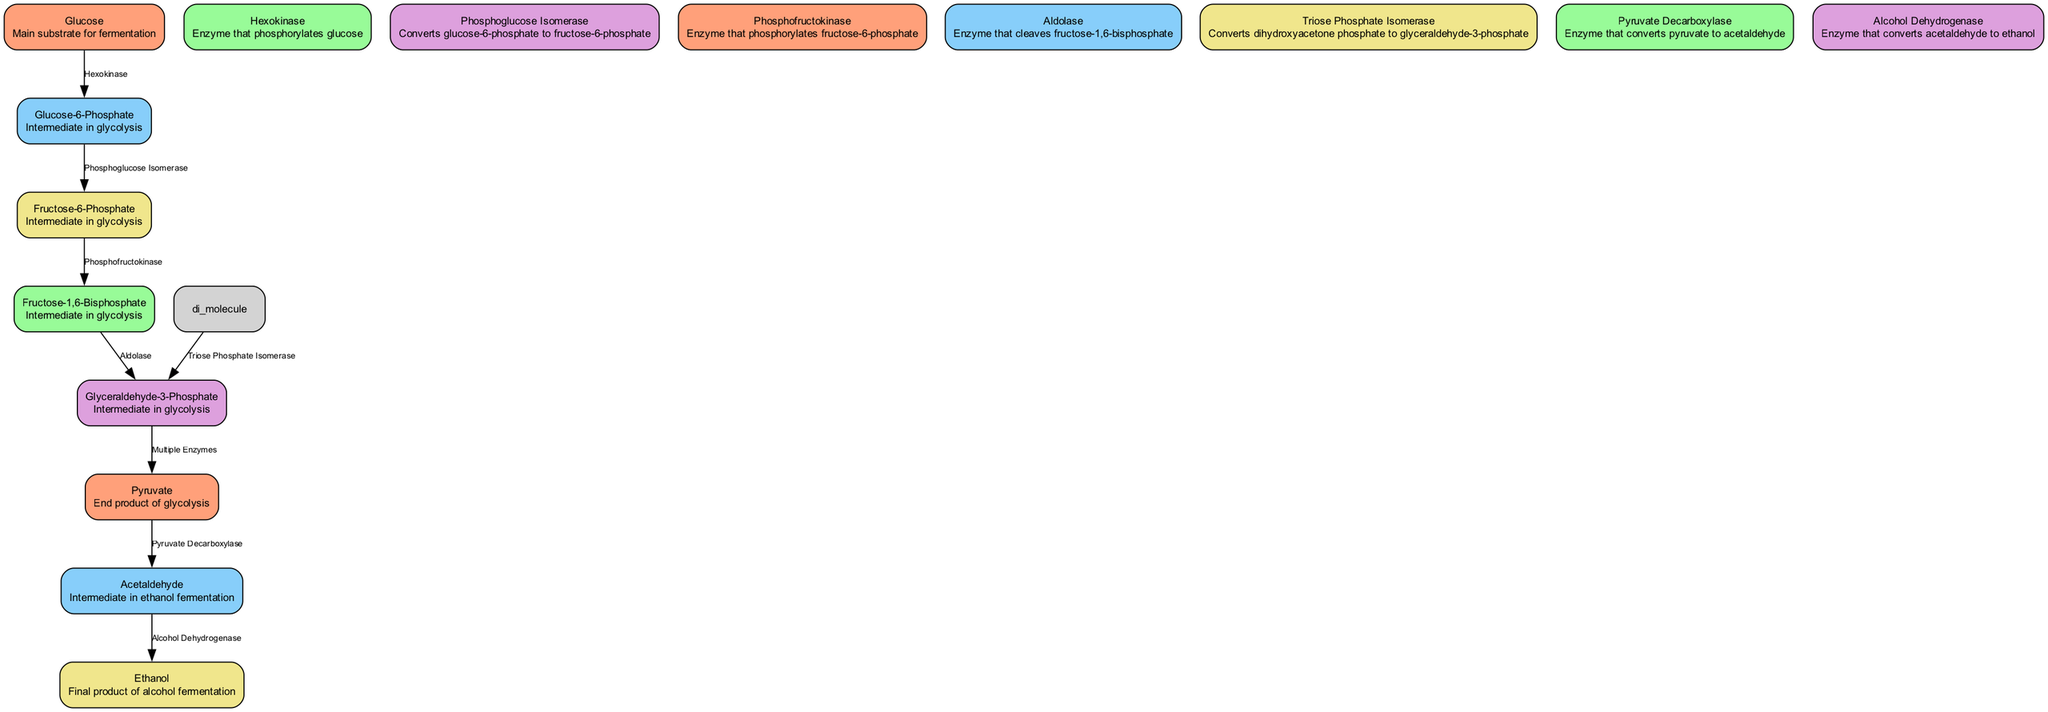What is the main substrate for fermentation? The diagram identifies 'Glucose' as the main substrate for fermentation. It is clearly labeled as "Main substrate for fermentation" in the node description.
Answer: Glucose How many edges are there in the diagram? By counting the number of connections between nodes, we determine there are 8 edges represented in the diagram, linking various steps in the fermentation process.
Answer: 8 Which enzyme converts pyruvate to acetaldehyde? 'Pyruvate Decarboxylase' is the enzyme responsible for converting pyruvate to acetaldehyde as indicated in the corresponding edge label within the diagram.
Answer: Pyruvate Decarboxylase What is the final product of alcohol fermentation? The diagram identifies 'Ethanol' as the final product of alcohol fermentation, as described in the label associated with the corresponding node.
Answer: Ethanol What enzyme phosphorylates fructose-6-phosphate? 'Phosphofructokinase' is labeled as the enzyme that phosphorylates fructose-6-phosphate, which can be found in the edge label connecting these two nodes in the diagram.
Answer: Phosphofructokinase Which two intermediates are formed before ethanol in the process? The series leading to ethanol involves 'Acetaldehyde' and 'Pyruvate' as intermediates, with each being the direct precursor to the next step in the pathway, shown in the flow of the diagram.
Answer: Acetaldehyde, Pyruvate What reaction does aldolase catalyze? 'Aldolase' catalyzes the reaction that cleaves fructose-1,6-bisphosphate into glyceraldehyde-3-phosphate, indicated clearly in the edge that connects these nodes visually in the diagram.
Answer: Cleaves fructose-1,6-bisphosphate Which step comes after the conversion of glucose to glucose-6-phosphate? Following the conversion of glucose to glucose-6-phosphate, the next step involves the conversion to fructose-6-phosphate by 'Phosphoglucose Isomerase', as depicted in the direct flow of the diagram.
Answer: Fructose-6-Phosphate What type of diagram is this? This diagram is classified as a Biomedical Diagram, specifically focusing on enzymatic activity within the context of alcohol fermentation.
Answer: Biomedical Diagram 